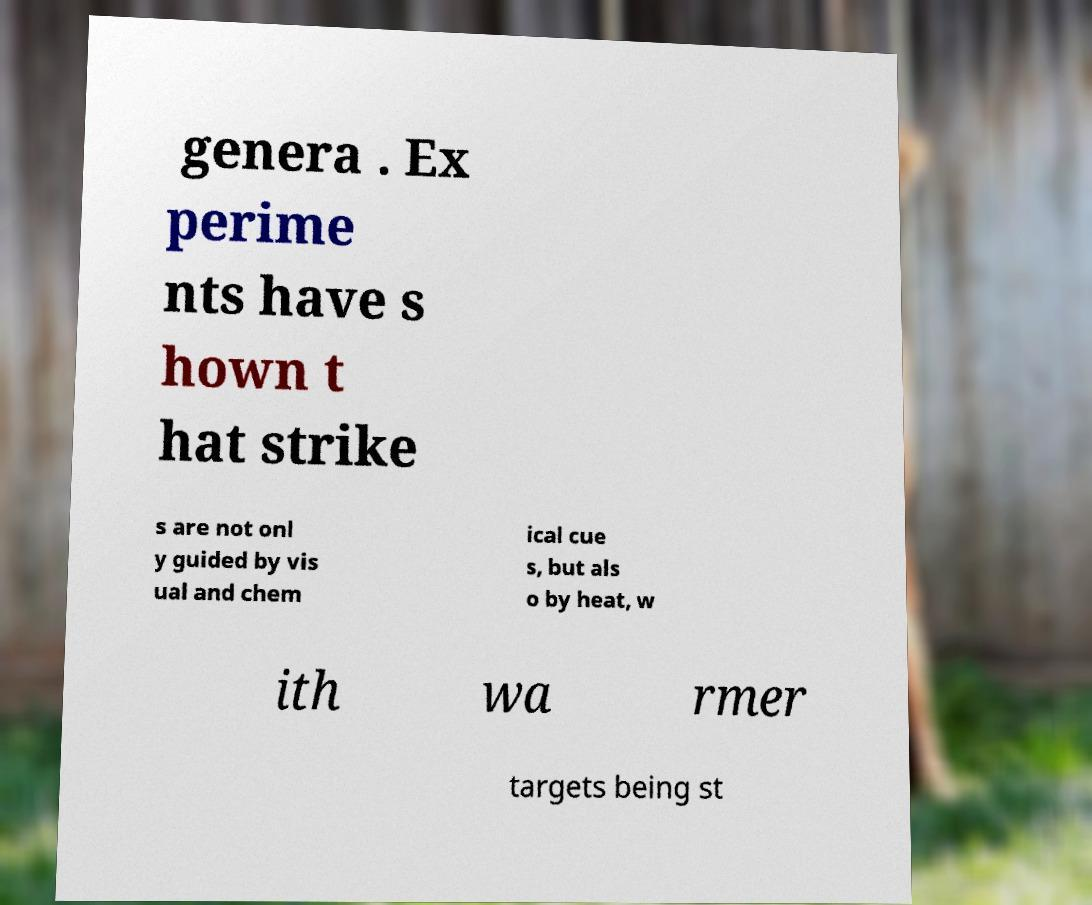Could you extract and type out the text from this image? genera . Ex perime nts have s hown t hat strike s are not onl y guided by vis ual and chem ical cue s, but als o by heat, w ith wa rmer targets being st 